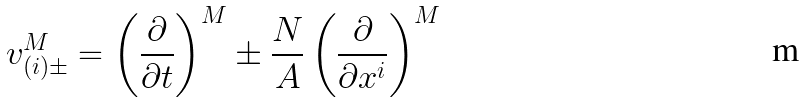Convert formula to latex. <formula><loc_0><loc_0><loc_500><loc_500>v _ { ( i ) \pm } ^ { M } = \left ( \frac { \partial } { \partial t } \right ) ^ { M } \pm \frac { N } { A } \left ( \frac { \partial } { \partial x ^ { i } } \right ) ^ { M }</formula> 